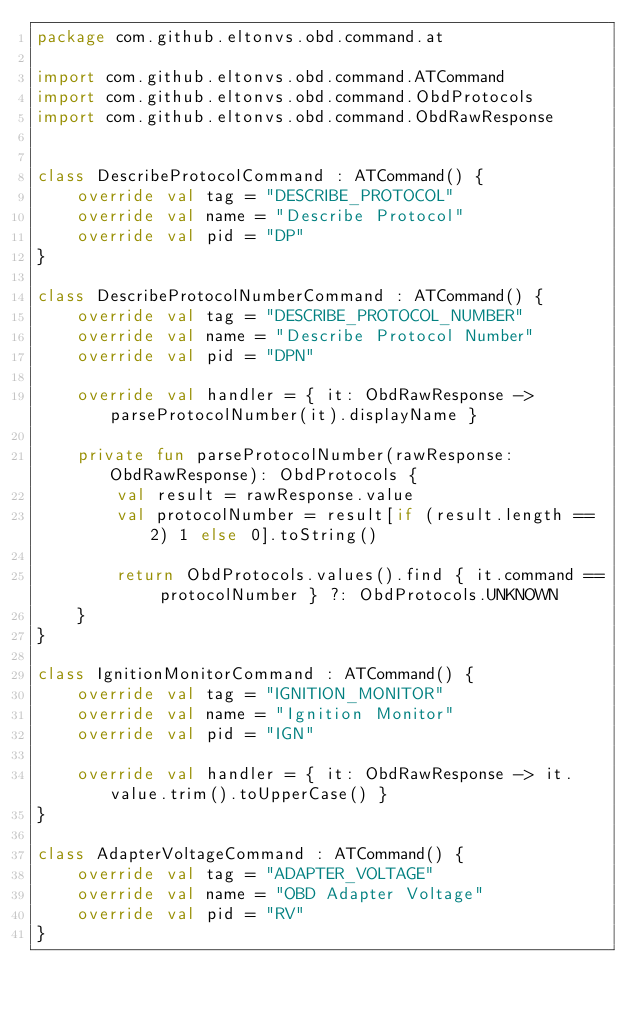<code> <loc_0><loc_0><loc_500><loc_500><_Kotlin_>package com.github.eltonvs.obd.command.at

import com.github.eltonvs.obd.command.ATCommand
import com.github.eltonvs.obd.command.ObdProtocols
import com.github.eltonvs.obd.command.ObdRawResponse


class DescribeProtocolCommand : ATCommand() {
    override val tag = "DESCRIBE_PROTOCOL"
    override val name = "Describe Protocol"
    override val pid = "DP"
}

class DescribeProtocolNumberCommand : ATCommand() {
    override val tag = "DESCRIBE_PROTOCOL_NUMBER"
    override val name = "Describe Protocol Number"
    override val pid = "DPN"

    override val handler = { it: ObdRawResponse -> parseProtocolNumber(it).displayName }

    private fun parseProtocolNumber(rawResponse: ObdRawResponse): ObdProtocols {
        val result = rawResponse.value
        val protocolNumber = result[if (result.length == 2) 1 else 0].toString()

        return ObdProtocols.values().find { it.command == protocolNumber } ?: ObdProtocols.UNKNOWN
    }
}

class IgnitionMonitorCommand : ATCommand() {
    override val tag = "IGNITION_MONITOR"
    override val name = "Ignition Monitor"
    override val pid = "IGN"

    override val handler = { it: ObdRawResponse -> it.value.trim().toUpperCase() }
}

class AdapterVoltageCommand : ATCommand() {
    override val tag = "ADAPTER_VOLTAGE"
    override val name = "OBD Adapter Voltage"
    override val pid = "RV"
}</code> 